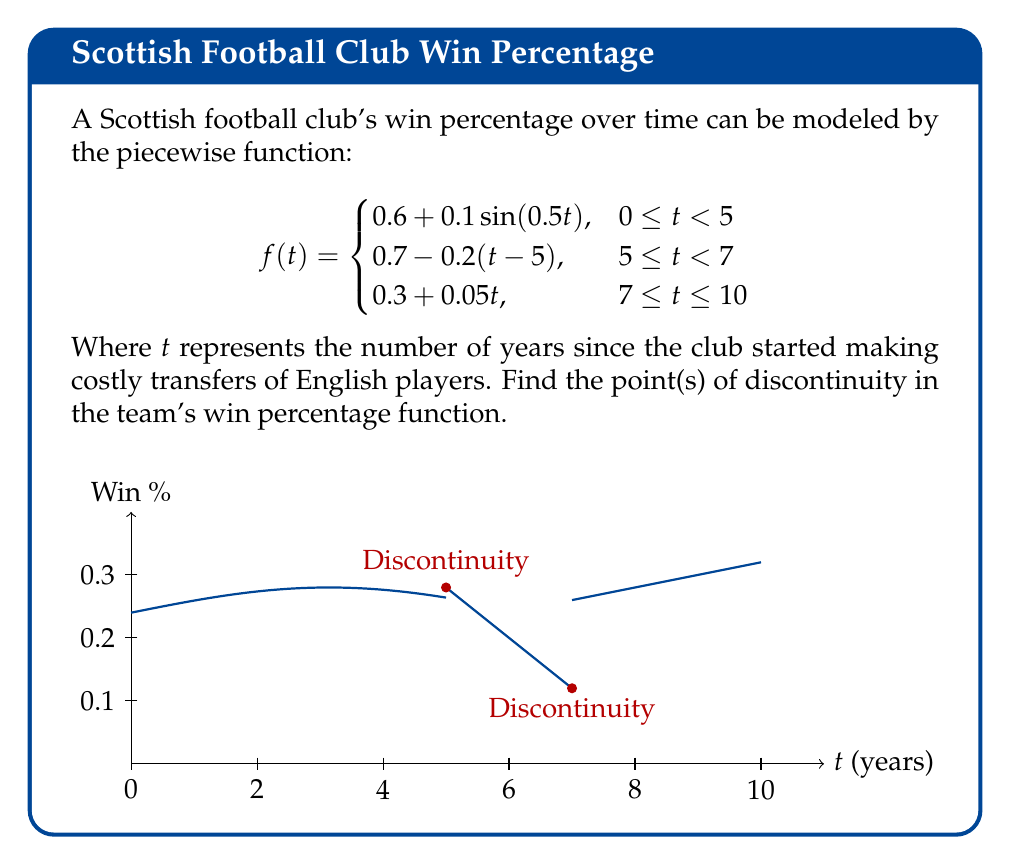Give your solution to this math problem. To find the points of discontinuity, we need to check for breaks in the function at the transition points between pieces:

1. At $t = 5$:
   Left limit: $\lim_{t \to 5^-} f(t) = 0.6 + 0.1\sin(0.5 \cdot 5) = 0.6 + 0.1\sin(2.5) \approx 0.6988$
   Right limit: $\lim_{t \to 5^+} f(t) = 0.7 - 0.2(5-5) = 0.7$
   The limits are different, so there's a discontinuity at $t = 5$.

2. At $t = 7$:
   Left limit: $\lim_{t \to 7^-} f(t) = 0.7 - 0.2(7-5) = 0.3$
   Right limit: $\lim_{t \to 7^+} f(t) = 0.3 + 0.05 \cdot 7 = 0.65$
   The limits are different, so there's also a discontinuity at $t = 7$.

Therefore, the function has discontinuities at both $t = 5$ and $t = 7$.
Answer: $t = 5$ and $t = 7$ 